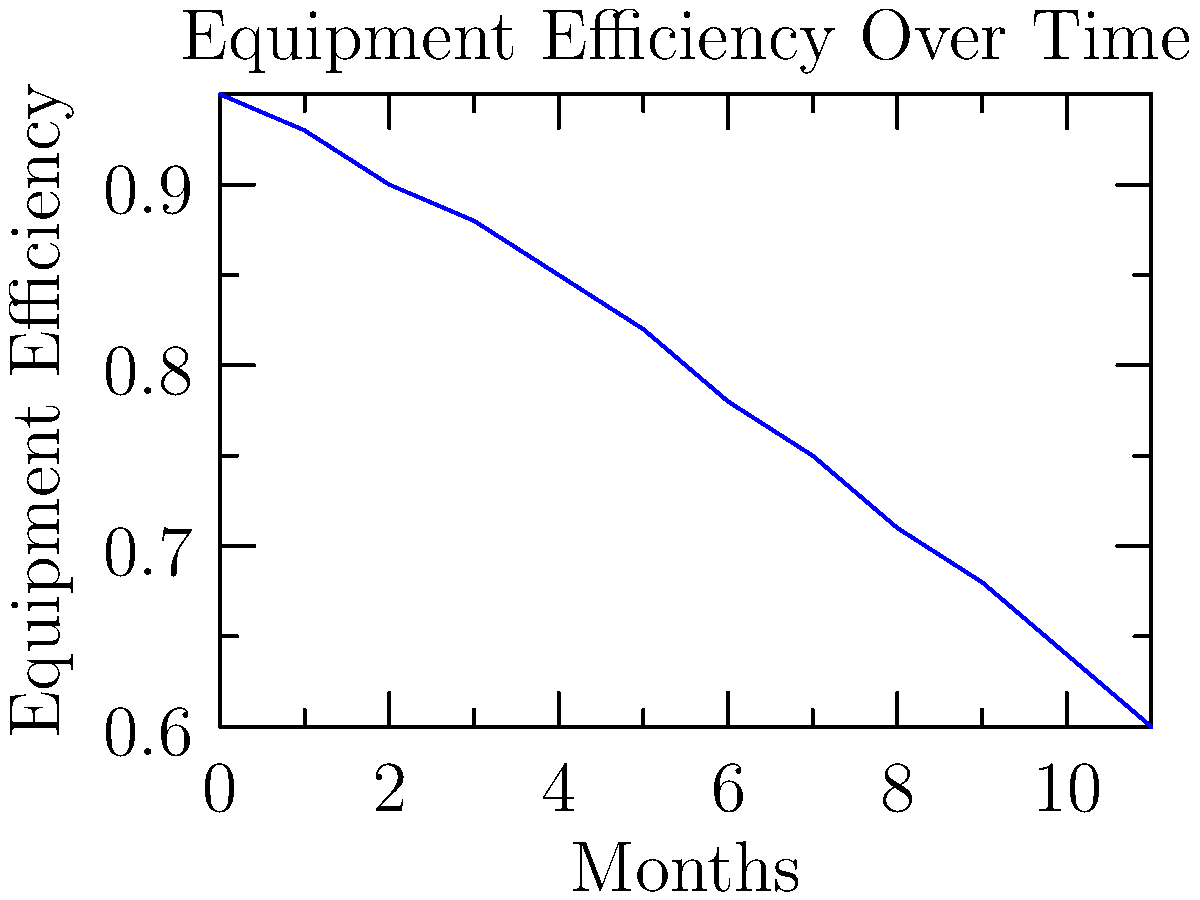Based on the equipment efficiency graph shown above, at what point (in months) should maintenance be scheduled to ensure efficiency doesn't drop below 70%? To determine when maintenance should be scheduled, we need to follow these steps:

1. Observe the trend in the graph: The equipment efficiency is decreasing over time.

2. Locate the target efficiency: We want to maintain efficiency above 70% (0.70 on the y-axis).

3. Find the intersection: Locate where the graph line crosses or approaches the 70% efficiency mark.

4. Read the corresponding x-axis value: This gives us the number of months before efficiency drops below 70%.

5. Analyze the data points:
   - At 7 months, efficiency is 0.75 (75%)
   - At 8 months, efficiency is 0.71 (71%)
   - At 9 months, efficiency is 0.68 (68%)

6. Conclude: To ensure efficiency doesn't drop below 70%, maintenance should be scheduled at or before 8 months.

7. Consider practical aspects: It's better to schedule maintenance slightly earlier to provide a safety margin and account for potential variations or unexpected issues.

Therefore, the optimal time to schedule maintenance would be around 7.5 months or earlier.
Answer: 7.5 months 